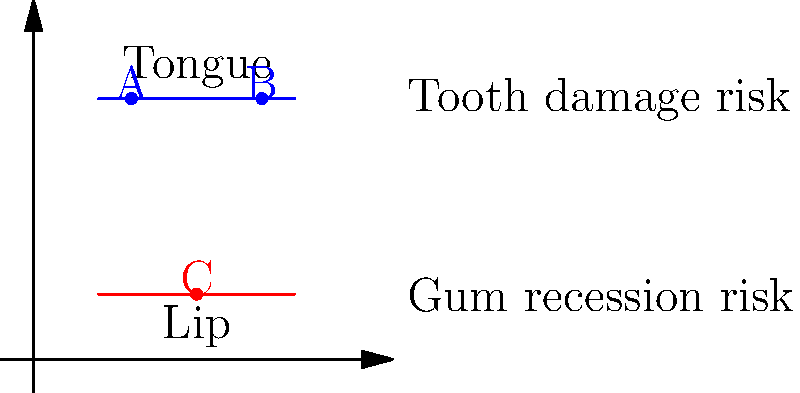Based on the diagram showing different oral piercing placements, which location poses the highest risk for both tooth damage and gum recession? To determine which piercing location poses the highest risk for both tooth damage and gum recession, let's analyze each position:

1. Position A: Located on the tongue, towards the front.
   - High risk for tooth damage due to constant contact with front teeth.
   - Lower risk for gum recession as it's not in direct contact with gums.

2. Position B: Located on the tongue, towards the back.
   - Lower risk for tooth damage as it has less contact with teeth.
   - Lower risk for gum recession as it's not in direct contact with gums.

3. Position C: Located on the lip.
   - High risk for tooth damage due to constant rubbing against front teeth.
   - High risk for gum recession as it's in direct contact with the gum line of the front teeth.

Comparing these positions:
- Position A has a high risk for tooth damage but lower risk for gum recession.
- Position B has lower risks for both tooth damage and gum recession.
- Position C has high risks for both tooth damage and gum recession.

Therefore, Position C (lip piercing) poses the highest risk for both tooth damage and gum recession.
Answer: Position C (lip piercing) 